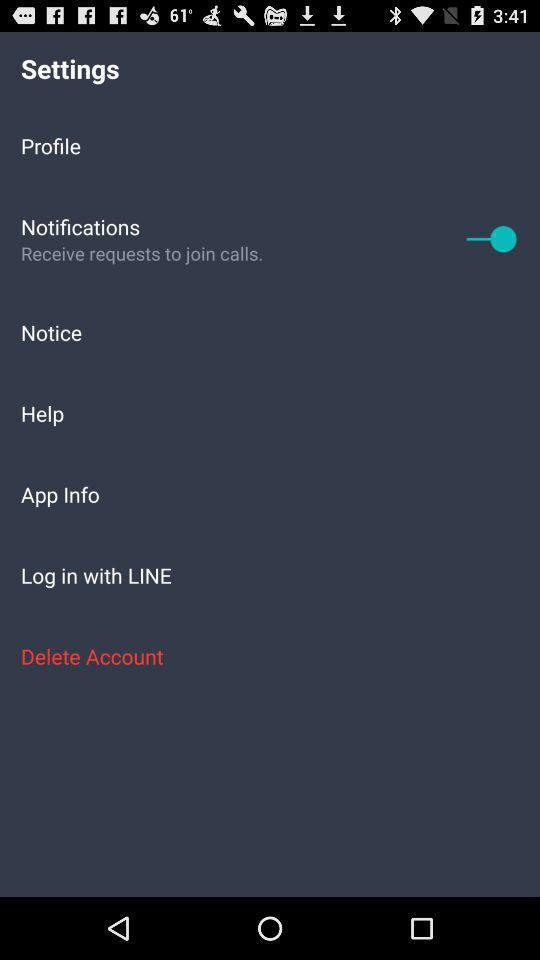How many items in the Settings menu have a switch?
Answer the question using a single word or phrase. 1 